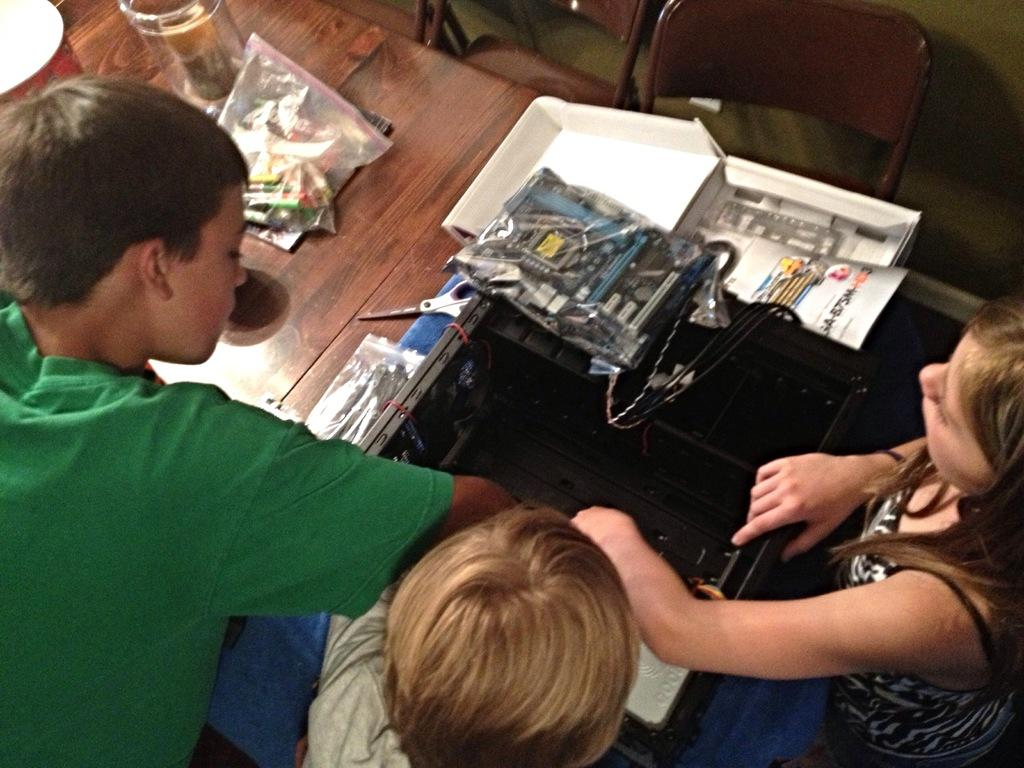Who is present in the image? There are children in the image. What furniture is visible in the image? There are chairs and a table in the image. What is on the table in the image? There is a jar, covers, boxes, and a scissor on the table. Can you describe the other objects on the table? There are other objects on the table, but their specific details are not mentioned in the provided facts. How does the guide help the children in the image? There is no guide present in the image; it only features children, chairs, a table, and various objects. 